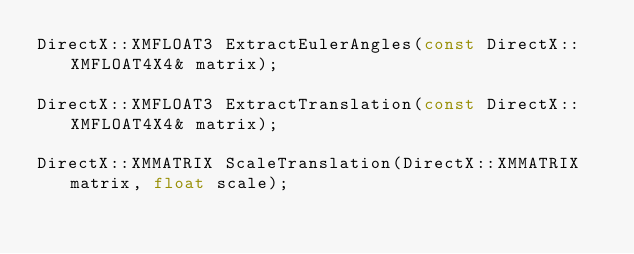<code> <loc_0><loc_0><loc_500><loc_500><_C_>DirectX::XMFLOAT3 ExtractEulerAngles(const DirectX::XMFLOAT4X4& matrix);

DirectX::XMFLOAT3 ExtractTranslation(const DirectX::XMFLOAT4X4& matrix);

DirectX::XMMATRIX ScaleTranslation(DirectX::XMMATRIX matrix, float scale);</code> 